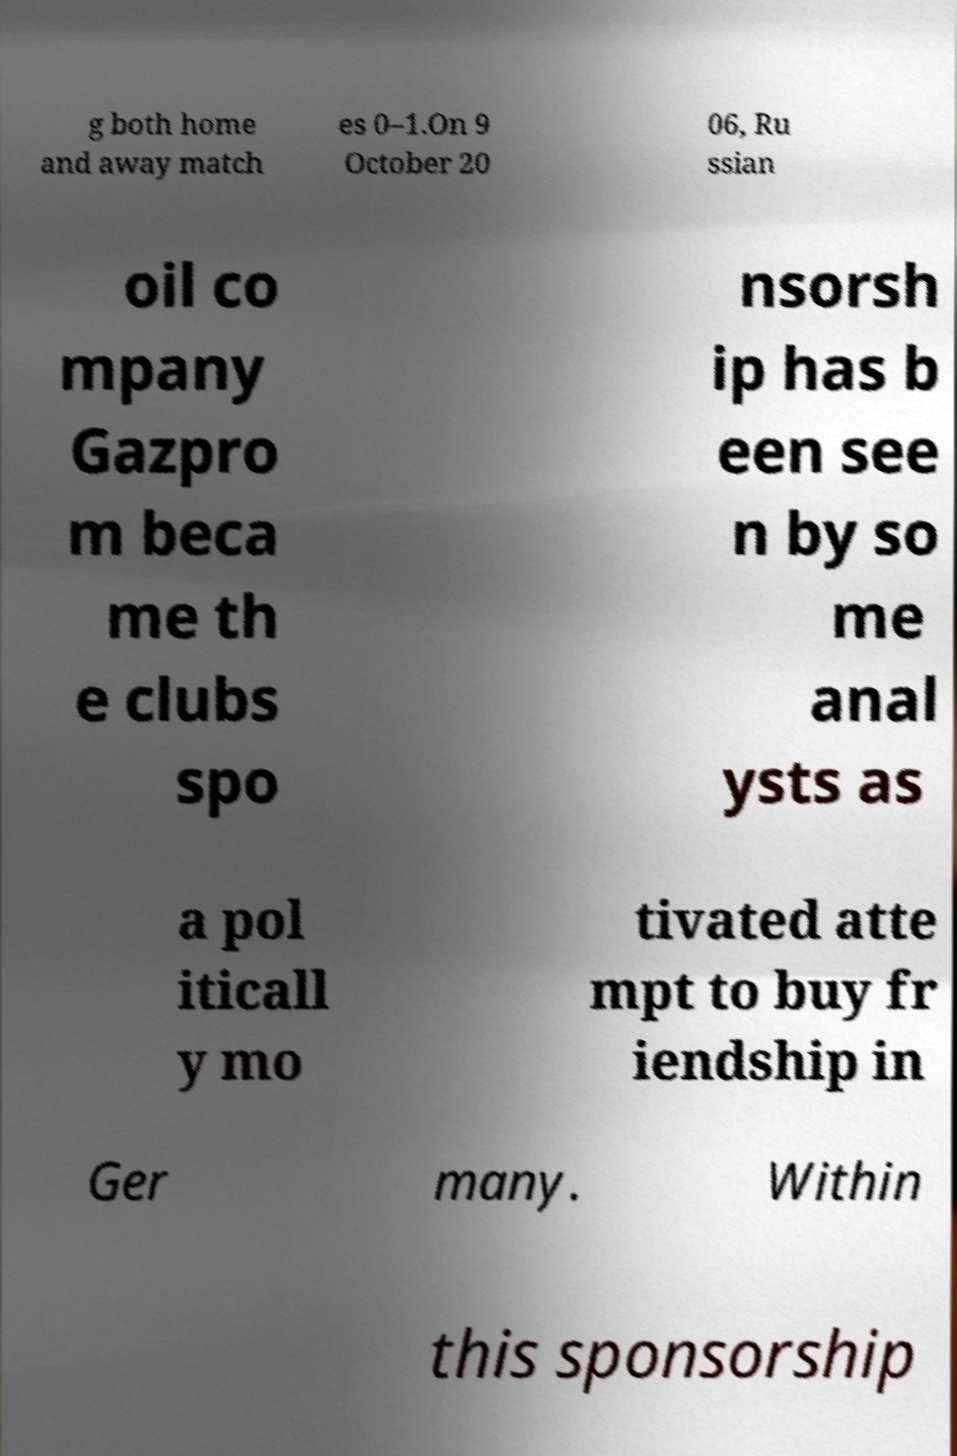Please read and relay the text visible in this image. What does it say? g both home and away match es 0–1.On 9 October 20 06, Ru ssian oil co mpany Gazpro m beca me th e clubs spo nsorsh ip has b een see n by so me anal ysts as a pol iticall y mo tivated atte mpt to buy fr iendship in Ger many. Within this sponsorship 